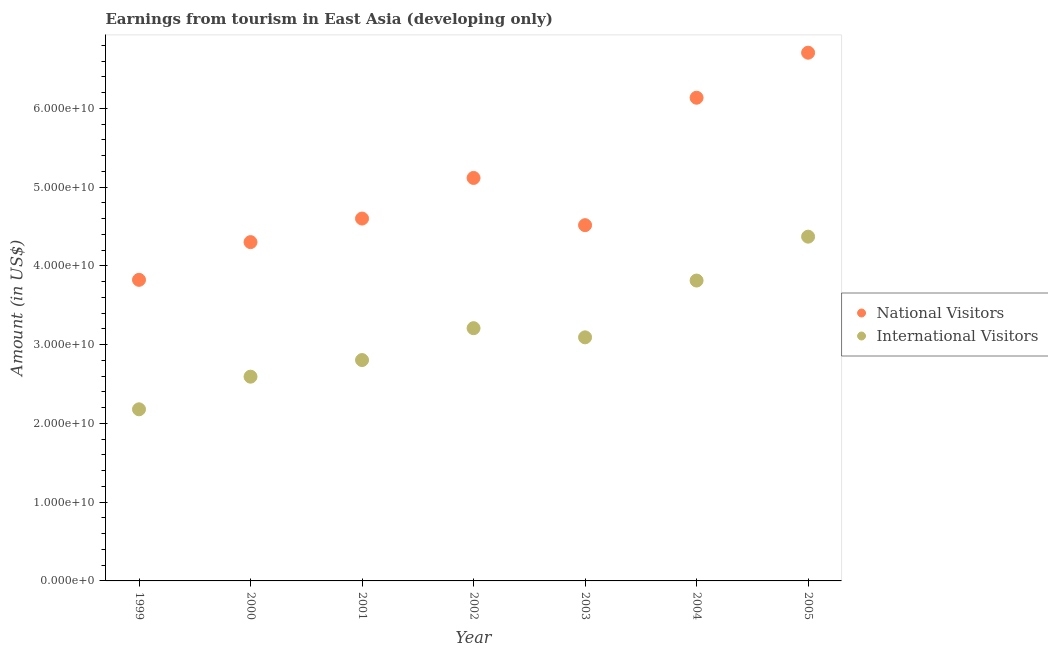What is the amount earned from national visitors in 2003?
Give a very brief answer. 4.52e+1. Across all years, what is the maximum amount earned from international visitors?
Your answer should be very brief. 4.37e+1. Across all years, what is the minimum amount earned from national visitors?
Keep it short and to the point. 3.82e+1. In which year was the amount earned from national visitors maximum?
Give a very brief answer. 2005. What is the total amount earned from international visitors in the graph?
Ensure brevity in your answer.  2.21e+11. What is the difference between the amount earned from international visitors in 1999 and that in 2000?
Ensure brevity in your answer.  -4.14e+09. What is the difference between the amount earned from international visitors in 2000 and the amount earned from national visitors in 2005?
Your response must be concise. -4.11e+1. What is the average amount earned from national visitors per year?
Make the answer very short. 5.03e+1. In the year 2005, what is the difference between the amount earned from national visitors and amount earned from international visitors?
Your response must be concise. 2.34e+1. In how many years, is the amount earned from national visitors greater than 34000000000 US$?
Provide a succinct answer. 7. What is the ratio of the amount earned from national visitors in 2000 to that in 2005?
Keep it short and to the point. 0.64. What is the difference between the highest and the second highest amount earned from international visitors?
Keep it short and to the point. 5.57e+09. What is the difference between the highest and the lowest amount earned from international visitors?
Offer a terse response. 2.19e+1. Is the sum of the amount earned from international visitors in 2001 and 2004 greater than the maximum amount earned from national visitors across all years?
Your answer should be very brief. No. Does the amount earned from international visitors monotonically increase over the years?
Offer a terse response. No. Is the amount earned from international visitors strictly less than the amount earned from national visitors over the years?
Keep it short and to the point. Yes. How many years are there in the graph?
Your response must be concise. 7. What is the difference between two consecutive major ticks on the Y-axis?
Make the answer very short. 1.00e+1. Where does the legend appear in the graph?
Keep it short and to the point. Center right. How many legend labels are there?
Offer a very short reply. 2. How are the legend labels stacked?
Your response must be concise. Vertical. What is the title of the graph?
Offer a terse response. Earnings from tourism in East Asia (developing only). What is the label or title of the X-axis?
Provide a short and direct response. Year. What is the Amount (in US$) of National Visitors in 1999?
Ensure brevity in your answer.  3.82e+1. What is the Amount (in US$) in International Visitors in 1999?
Your response must be concise. 2.18e+1. What is the Amount (in US$) of National Visitors in 2000?
Offer a terse response. 4.30e+1. What is the Amount (in US$) in International Visitors in 2000?
Your answer should be compact. 2.59e+1. What is the Amount (in US$) in National Visitors in 2001?
Give a very brief answer. 4.60e+1. What is the Amount (in US$) in International Visitors in 2001?
Your answer should be very brief. 2.80e+1. What is the Amount (in US$) in National Visitors in 2002?
Keep it short and to the point. 5.12e+1. What is the Amount (in US$) in International Visitors in 2002?
Offer a terse response. 3.21e+1. What is the Amount (in US$) of National Visitors in 2003?
Make the answer very short. 4.52e+1. What is the Amount (in US$) of International Visitors in 2003?
Your response must be concise. 3.09e+1. What is the Amount (in US$) of National Visitors in 2004?
Ensure brevity in your answer.  6.13e+1. What is the Amount (in US$) in International Visitors in 2004?
Provide a succinct answer. 3.81e+1. What is the Amount (in US$) of National Visitors in 2005?
Ensure brevity in your answer.  6.71e+1. What is the Amount (in US$) in International Visitors in 2005?
Your answer should be compact. 4.37e+1. Across all years, what is the maximum Amount (in US$) of National Visitors?
Ensure brevity in your answer.  6.71e+1. Across all years, what is the maximum Amount (in US$) in International Visitors?
Ensure brevity in your answer.  4.37e+1. Across all years, what is the minimum Amount (in US$) of National Visitors?
Provide a short and direct response. 3.82e+1. Across all years, what is the minimum Amount (in US$) in International Visitors?
Your answer should be very brief. 2.18e+1. What is the total Amount (in US$) in National Visitors in the graph?
Make the answer very short. 3.52e+11. What is the total Amount (in US$) in International Visitors in the graph?
Provide a succinct answer. 2.21e+11. What is the difference between the Amount (in US$) of National Visitors in 1999 and that in 2000?
Offer a terse response. -4.79e+09. What is the difference between the Amount (in US$) in International Visitors in 1999 and that in 2000?
Offer a terse response. -4.14e+09. What is the difference between the Amount (in US$) of National Visitors in 1999 and that in 2001?
Provide a short and direct response. -7.78e+09. What is the difference between the Amount (in US$) of International Visitors in 1999 and that in 2001?
Offer a very short reply. -6.25e+09. What is the difference between the Amount (in US$) in National Visitors in 1999 and that in 2002?
Offer a terse response. -1.29e+1. What is the difference between the Amount (in US$) in International Visitors in 1999 and that in 2002?
Make the answer very short. -1.03e+1. What is the difference between the Amount (in US$) of National Visitors in 1999 and that in 2003?
Your response must be concise. -6.94e+09. What is the difference between the Amount (in US$) of International Visitors in 1999 and that in 2003?
Provide a succinct answer. -9.14e+09. What is the difference between the Amount (in US$) in National Visitors in 1999 and that in 2004?
Keep it short and to the point. -2.31e+1. What is the difference between the Amount (in US$) in International Visitors in 1999 and that in 2004?
Give a very brief answer. -1.63e+1. What is the difference between the Amount (in US$) in National Visitors in 1999 and that in 2005?
Your answer should be compact. -2.88e+1. What is the difference between the Amount (in US$) in International Visitors in 1999 and that in 2005?
Keep it short and to the point. -2.19e+1. What is the difference between the Amount (in US$) in National Visitors in 2000 and that in 2001?
Provide a succinct answer. -2.99e+09. What is the difference between the Amount (in US$) in International Visitors in 2000 and that in 2001?
Keep it short and to the point. -2.11e+09. What is the difference between the Amount (in US$) in National Visitors in 2000 and that in 2002?
Your response must be concise. -8.15e+09. What is the difference between the Amount (in US$) of International Visitors in 2000 and that in 2002?
Give a very brief answer. -6.16e+09. What is the difference between the Amount (in US$) in National Visitors in 2000 and that in 2003?
Your answer should be very brief. -2.15e+09. What is the difference between the Amount (in US$) of International Visitors in 2000 and that in 2003?
Provide a succinct answer. -5.00e+09. What is the difference between the Amount (in US$) of National Visitors in 2000 and that in 2004?
Your answer should be compact. -1.83e+1. What is the difference between the Amount (in US$) in International Visitors in 2000 and that in 2004?
Offer a very short reply. -1.22e+1. What is the difference between the Amount (in US$) of National Visitors in 2000 and that in 2005?
Make the answer very short. -2.40e+1. What is the difference between the Amount (in US$) of International Visitors in 2000 and that in 2005?
Your answer should be very brief. -1.78e+1. What is the difference between the Amount (in US$) of National Visitors in 2001 and that in 2002?
Offer a very short reply. -5.16e+09. What is the difference between the Amount (in US$) of International Visitors in 2001 and that in 2002?
Provide a short and direct response. -4.05e+09. What is the difference between the Amount (in US$) of National Visitors in 2001 and that in 2003?
Provide a short and direct response. 8.39e+08. What is the difference between the Amount (in US$) in International Visitors in 2001 and that in 2003?
Make the answer very short. -2.88e+09. What is the difference between the Amount (in US$) of National Visitors in 2001 and that in 2004?
Provide a short and direct response. -1.53e+1. What is the difference between the Amount (in US$) in International Visitors in 2001 and that in 2004?
Give a very brief answer. -1.01e+1. What is the difference between the Amount (in US$) of National Visitors in 2001 and that in 2005?
Ensure brevity in your answer.  -2.11e+1. What is the difference between the Amount (in US$) in International Visitors in 2001 and that in 2005?
Give a very brief answer. -1.57e+1. What is the difference between the Amount (in US$) in National Visitors in 2002 and that in 2003?
Offer a very short reply. 5.99e+09. What is the difference between the Amount (in US$) in International Visitors in 2002 and that in 2003?
Keep it short and to the point. 1.16e+09. What is the difference between the Amount (in US$) in National Visitors in 2002 and that in 2004?
Keep it short and to the point. -1.02e+1. What is the difference between the Amount (in US$) of International Visitors in 2002 and that in 2004?
Offer a very short reply. -6.05e+09. What is the difference between the Amount (in US$) in National Visitors in 2002 and that in 2005?
Offer a terse response. -1.59e+1. What is the difference between the Amount (in US$) of International Visitors in 2002 and that in 2005?
Give a very brief answer. -1.16e+1. What is the difference between the Amount (in US$) of National Visitors in 2003 and that in 2004?
Your answer should be compact. -1.62e+1. What is the difference between the Amount (in US$) of International Visitors in 2003 and that in 2004?
Keep it short and to the point. -7.21e+09. What is the difference between the Amount (in US$) of National Visitors in 2003 and that in 2005?
Your answer should be very brief. -2.19e+1. What is the difference between the Amount (in US$) in International Visitors in 2003 and that in 2005?
Provide a short and direct response. -1.28e+1. What is the difference between the Amount (in US$) of National Visitors in 2004 and that in 2005?
Offer a terse response. -5.72e+09. What is the difference between the Amount (in US$) of International Visitors in 2004 and that in 2005?
Your answer should be very brief. -5.57e+09. What is the difference between the Amount (in US$) in National Visitors in 1999 and the Amount (in US$) in International Visitors in 2000?
Your answer should be compact. 1.23e+1. What is the difference between the Amount (in US$) in National Visitors in 1999 and the Amount (in US$) in International Visitors in 2001?
Keep it short and to the point. 1.02e+1. What is the difference between the Amount (in US$) in National Visitors in 1999 and the Amount (in US$) in International Visitors in 2002?
Give a very brief answer. 6.14e+09. What is the difference between the Amount (in US$) in National Visitors in 1999 and the Amount (in US$) in International Visitors in 2003?
Offer a terse response. 7.30e+09. What is the difference between the Amount (in US$) of National Visitors in 1999 and the Amount (in US$) of International Visitors in 2004?
Your answer should be very brief. 9.03e+07. What is the difference between the Amount (in US$) of National Visitors in 1999 and the Amount (in US$) of International Visitors in 2005?
Offer a terse response. -5.48e+09. What is the difference between the Amount (in US$) in National Visitors in 2000 and the Amount (in US$) in International Visitors in 2001?
Ensure brevity in your answer.  1.50e+1. What is the difference between the Amount (in US$) of National Visitors in 2000 and the Amount (in US$) of International Visitors in 2002?
Keep it short and to the point. 1.09e+1. What is the difference between the Amount (in US$) of National Visitors in 2000 and the Amount (in US$) of International Visitors in 2003?
Provide a succinct answer. 1.21e+1. What is the difference between the Amount (in US$) in National Visitors in 2000 and the Amount (in US$) in International Visitors in 2004?
Give a very brief answer. 4.88e+09. What is the difference between the Amount (in US$) of National Visitors in 2000 and the Amount (in US$) of International Visitors in 2005?
Your response must be concise. -6.93e+08. What is the difference between the Amount (in US$) in National Visitors in 2001 and the Amount (in US$) in International Visitors in 2002?
Your response must be concise. 1.39e+1. What is the difference between the Amount (in US$) in National Visitors in 2001 and the Amount (in US$) in International Visitors in 2003?
Make the answer very short. 1.51e+1. What is the difference between the Amount (in US$) of National Visitors in 2001 and the Amount (in US$) of International Visitors in 2004?
Offer a terse response. 7.87e+09. What is the difference between the Amount (in US$) in National Visitors in 2001 and the Amount (in US$) in International Visitors in 2005?
Your answer should be compact. 2.30e+09. What is the difference between the Amount (in US$) of National Visitors in 2002 and the Amount (in US$) of International Visitors in 2003?
Keep it short and to the point. 2.02e+1. What is the difference between the Amount (in US$) of National Visitors in 2002 and the Amount (in US$) of International Visitors in 2004?
Offer a terse response. 1.30e+1. What is the difference between the Amount (in US$) in National Visitors in 2002 and the Amount (in US$) in International Visitors in 2005?
Give a very brief answer. 7.45e+09. What is the difference between the Amount (in US$) of National Visitors in 2003 and the Amount (in US$) of International Visitors in 2004?
Provide a succinct answer. 7.03e+09. What is the difference between the Amount (in US$) of National Visitors in 2003 and the Amount (in US$) of International Visitors in 2005?
Your answer should be very brief. 1.46e+09. What is the difference between the Amount (in US$) of National Visitors in 2004 and the Amount (in US$) of International Visitors in 2005?
Your answer should be compact. 1.76e+1. What is the average Amount (in US$) in National Visitors per year?
Provide a short and direct response. 5.03e+1. What is the average Amount (in US$) of International Visitors per year?
Offer a very short reply. 3.15e+1. In the year 1999, what is the difference between the Amount (in US$) of National Visitors and Amount (in US$) of International Visitors?
Give a very brief answer. 1.64e+1. In the year 2000, what is the difference between the Amount (in US$) in National Visitors and Amount (in US$) in International Visitors?
Your answer should be compact. 1.71e+1. In the year 2001, what is the difference between the Amount (in US$) of National Visitors and Amount (in US$) of International Visitors?
Provide a short and direct response. 1.80e+1. In the year 2002, what is the difference between the Amount (in US$) of National Visitors and Amount (in US$) of International Visitors?
Provide a succinct answer. 1.91e+1. In the year 2003, what is the difference between the Amount (in US$) of National Visitors and Amount (in US$) of International Visitors?
Ensure brevity in your answer.  1.42e+1. In the year 2004, what is the difference between the Amount (in US$) of National Visitors and Amount (in US$) of International Visitors?
Provide a succinct answer. 2.32e+1. In the year 2005, what is the difference between the Amount (in US$) of National Visitors and Amount (in US$) of International Visitors?
Make the answer very short. 2.34e+1. What is the ratio of the Amount (in US$) of National Visitors in 1999 to that in 2000?
Give a very brief answer. 0.89. What is the ratio of the Amount (in US$) of International Visitors in 1999 to that in 2000?
Offer a terse response. 0.84. What is the ratio of the Amount (in US$) of National Visitors in 1999 to that in 2001?
Offer a very short reply. 0.83. What is the ratio of the Amount (in US$) of International Visitors in 1999 to that in 2001?
Offer a terse response. 0.78. What is the ratio of the Amount (in US$) in National Visitors in 1999 to that in 2002?
Your answer should be very brief. 0.75. What is the ratio of the Amount (in US$) of International Visitors in 1999 to that in 2002?
Give a very brief answer. 0.68. What is the ratio of the Amount (in US$) in National Visitors in 1999 to that in 2003?
Provide a short and direct response. 0.85. What is the ratio of the Amount (in US$) of International Visitors in 1999 to that in 2003?
Your answer should be compact. 0.7. What is the ratio of the Amount (in US$) of National Visitors in 1999 to that in 2004?
Your answer should be very brief. 0.62. What is the ratio of the Amount (in US$) in International Visitors in 1999 to that in 2004?
Give a very brief answer. 0.57. What is the ratio of the Amount (in US$) in National Visitors in 1999 to that in 2005?
Offer a very short reply. 0.57. What is the ratio of the Amount (in US$) of International Visitors in 1999 to that in 2005?
Offer a very short reply. 0.5. What is the ratio of the Amount (in US$) of National Visitors in 2000 to that in 2001?
Your answer should be compact. 0.94. What is the ratio of the Amount (in US$) of International Visitors in 2000 to that in 2001?
Provide a short and direct response. 0.92. What is the ratio of the Amount (in US$) of National Visitors in 2000 to that in 2002?
Offer a very short reply. 0.84. What is the ratio of the Amount (in US$) in International Visitors in 2000 to that in 2002?
Ensure brevity in your answer.  0.81. What is the ratio of the Amount (in US$) of International Visitors in 2000 to that in 2003?
Offer a terse response. 0.84. What is the ratio of the Amount (in US$) of National Visitors in 2000 to that in 2004?
Offer a terse response. 0.7. What is the ratio of the Amount (in US$) of International Visitors in 2000 to that in 2004?
Provide a short and direct response. 0.68. What is the ratio of the Amount (in US$) in National Visitors in 2000 to that in 2005?
Give a very brief answer. 0.64. What is the ratio of the Amount (in US$) of International Visitors in 2000 to that in 2005?
Your response must be concise. 0.59. What is the ratio of the Amount (in US$) in National Visitors in 2001 to that in 2002?
Offer a terse response. 0.9. What is the ratio of the Amount (in US$) of International Visitors in 2001 to that in 2002?
Provide a succinct answer. 0.87. What is the ratio of the Amount (in US$) in National Visitors in 2001 to that in 2003?
Offer a terse response. 1.02. What is the ratio of the Amount (in US$) of International Visitors in 2001 to that in 2003?
Offer a terse response. 0.91. What is the ratio of the Amount (in US$) of National Visitors in 2001 to that in 2004?
Ensure brevity in your answer.  0.75. What is the ratio of the Amount (in US$) in International Visitors in 2001 to that in 2004?
Your answer should be very brief. 0.74. What is the ratio of the Amount (in US$) of National Visitors in 2001 to that in 2005?
Offer a very short reply. 0.69. What is the ratio of the Amount (in US$) of International Visitors in 2001 to that in 2005?
Your answer should be very brief. 0.64. What is the ratio of the Amount (in US$) of National Visitors in 2002 to that in 2003?
Your answer should be very brief. 1.13. What is the ratio of the Amount (in US$) in International Visitors in 2002 to that in 2003?
Your answer should be compact. 1.04. What is the ratio of the Amount (in US$) in National Visitors in 2002 to that in 2004?
Give a very brief answer. 0.83. What is the ratio of the Amount (in US$) in International Visitors in 2002 to that in 2004?
Keep it short and to the point. 0.84. What is the ratio of the Amount (in US$) of National Visitors in 2002 to that in 2005?
Ensure brevity in your answer.  0.76. What is the ratio of the Amount (in US$) of International Visitors in 2002 to that in 2005?
Give a very brief answer. 0.73. What is the ratio of the Amount (in US$) of National Visitors in 2003 to that in 2004?
Your answer should be very brief. 0.74. What is the ratio of the Amount (in US$) in International Visitors in 2003 to that in 2004?
Provide a succinct answer. 0.81. What is the ratio of the Amount (in US$) of National Visitors in 2003 to that in 2005?
Provide a short and direct response. 0.67. What is the ratio of the Amount (in US$) in International Visitors in 2003 to that in 2005?
Give a very brief answer. 0.71. What is the ratio of the Amount (in US$) in National Visitors in 2004 to that in 2005?
Offer a very short reply. 0.91. What is the ratio of the Amount (in US$) in International Visitors in 2004 to that in 2005?
Provide a short and direct response. 0.87. What is the difference between the highest and the second highest Amount (in US$) in National Visitors?
Your answer should be very brief. 5.72e+09. What is the difference between the highest and the second highest Amount (in US$) in International Visitors?
Give a very brief answer. 5.57e+09. What is the difference between the highest and the lowest Amount (in US$) in National Visitors?
Your response must be concise. 2.88e+1. What is the difference between the highest and the lowest Amount (in US$) of International Visitors?
Offer a terse response. 2.19e+1. 